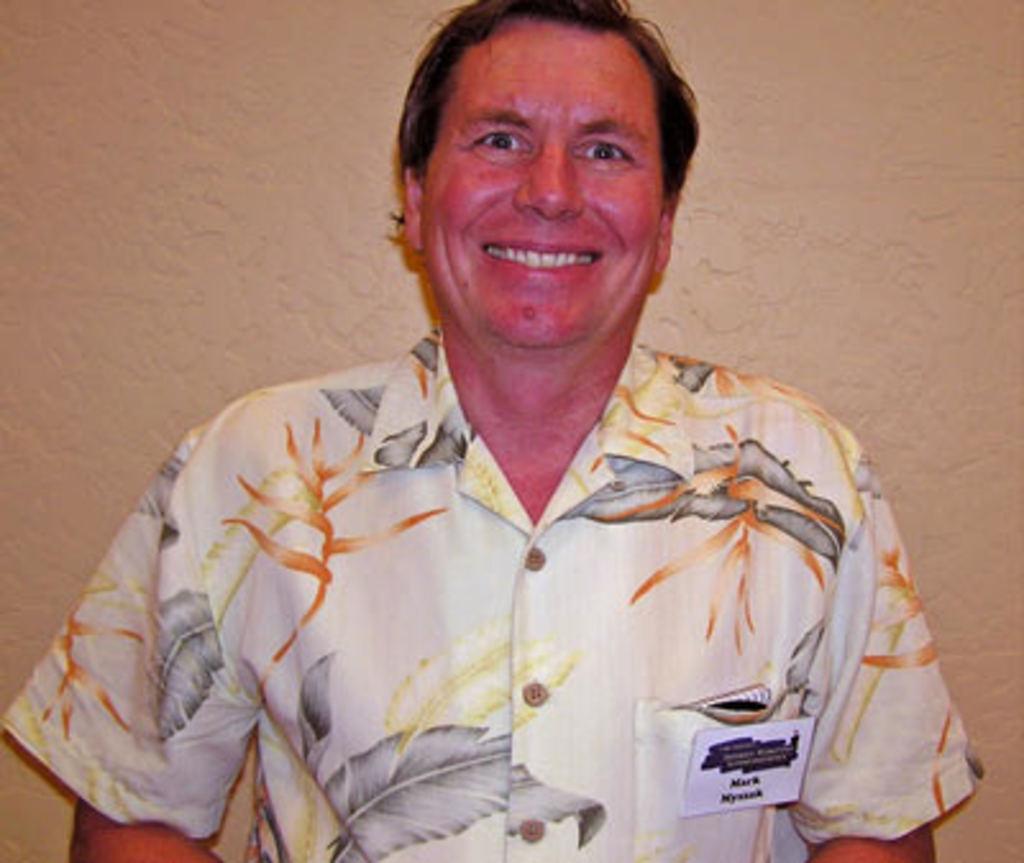In one or two sentences, can you explain what this image depicts? In this image there is a person with a smile on his face. In the background there is a wall. 